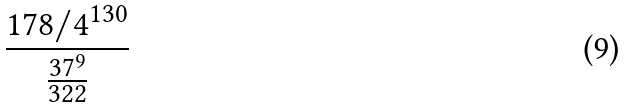<formula> <loc_0><loc_0><loc_500><loc_500>\frac { 1 7 8 / 4 ^ { 1 3 0 } } { \frac { 3 7 ^ { 9 } } { 3 2 2 } }</formula> 